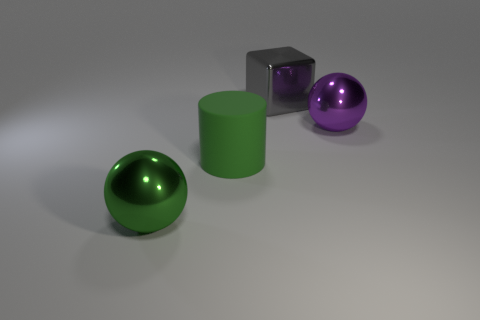There is a object that is the same color as the large cylinder; what shape is it?
Offer a very short reply. Sphere. Is there any other thing that is the same material as the green ball?
Offer a terse response. Yes. Is the number of large purple metal balls that are in front of the big purple object less than the number of large gray objects?
Ensure brevity in your answer.  Yes. Are there more large gray cubes in front of the big purple sphere than big cylinders on the right side of the big gray object?
Provide a short and direct response. No. Is there anything else that is the same color as the large cylinder?
Your response must be concise. Yes. There is a thing that is right of the gray metal object; what is it made of?
Offer a very short reply. Metal. Is the block the same size as the purple metal sphere?
Your response must be concise. Yes. What number of other things are there of the same size as the green rubber object?
Provide a short and direct response. 3. Is the big rubber object the same color as the block?
Ensure brevity in your answer.  No. The green object on the right side of the metallic thing that is in front of the metallic sphere that is to the right of the large green cylinder is what shape?
Your answer should be very brief. Cylinder. 